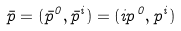<formula> <loc_0><loc_0><loc_500><loc_500>\bar { p } = ( { \bar { p } } ^ { 0 } , { \bar { p } } ^ { i } ) = ( i p ^ { 0 } , p ^ { i } )</formula> 